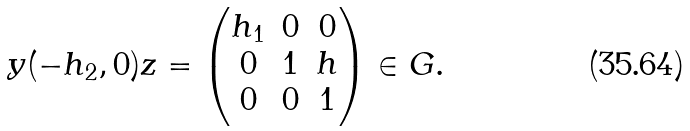Convert formula to latex. <formula><loc_0><loc_0><loc_500><loc_500>y ( - h _ { 2 } , 0 ) z = \begin{pmatrix} h _ { 1 } & 0 & 0 \\ 0 & 1 & h \\ 0 & 0 & 1 \end{pmatrix} \in G .</formula> 